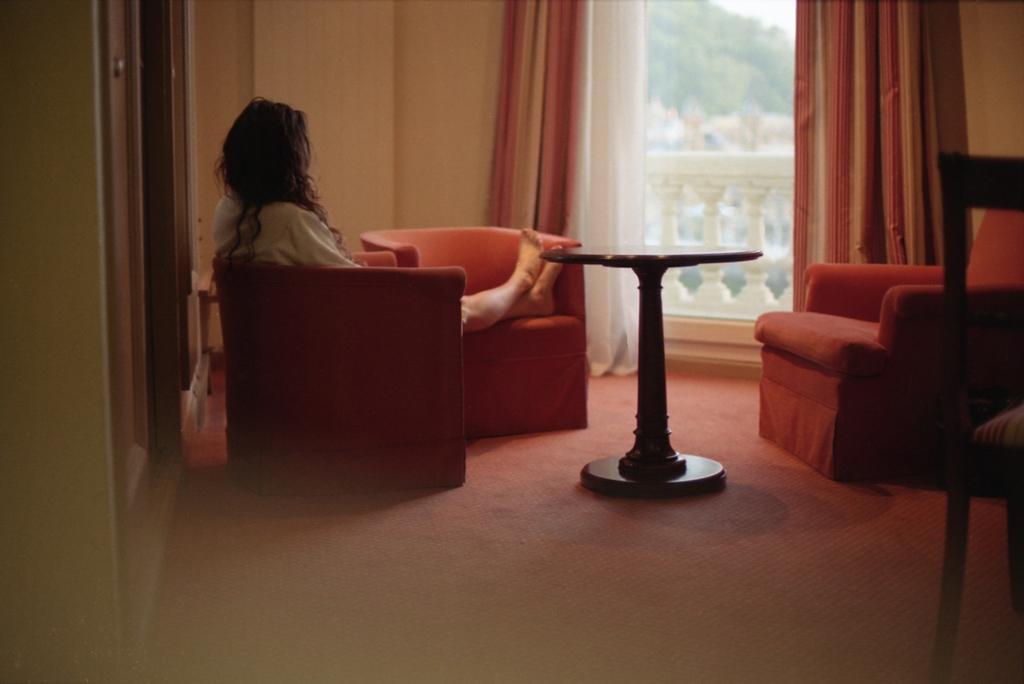How would you summarize this image in a sentence or two? In the foreground of this image, there is a chair on the right side. In the background, there is a woman sitting on the chair, a table, on another chair, floor, cupboards, wall, curtain and a window. 